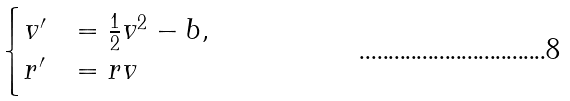Convert formula to latex. <formula><loc_0><loc_0><loc_500><loc_500>\begin{cases} v ^ { \prime } & = \frac { 1 } { 2 } v ^ { 2 } - b , \\ r ^ { \prime } & = r v \end{cases}</formula> 